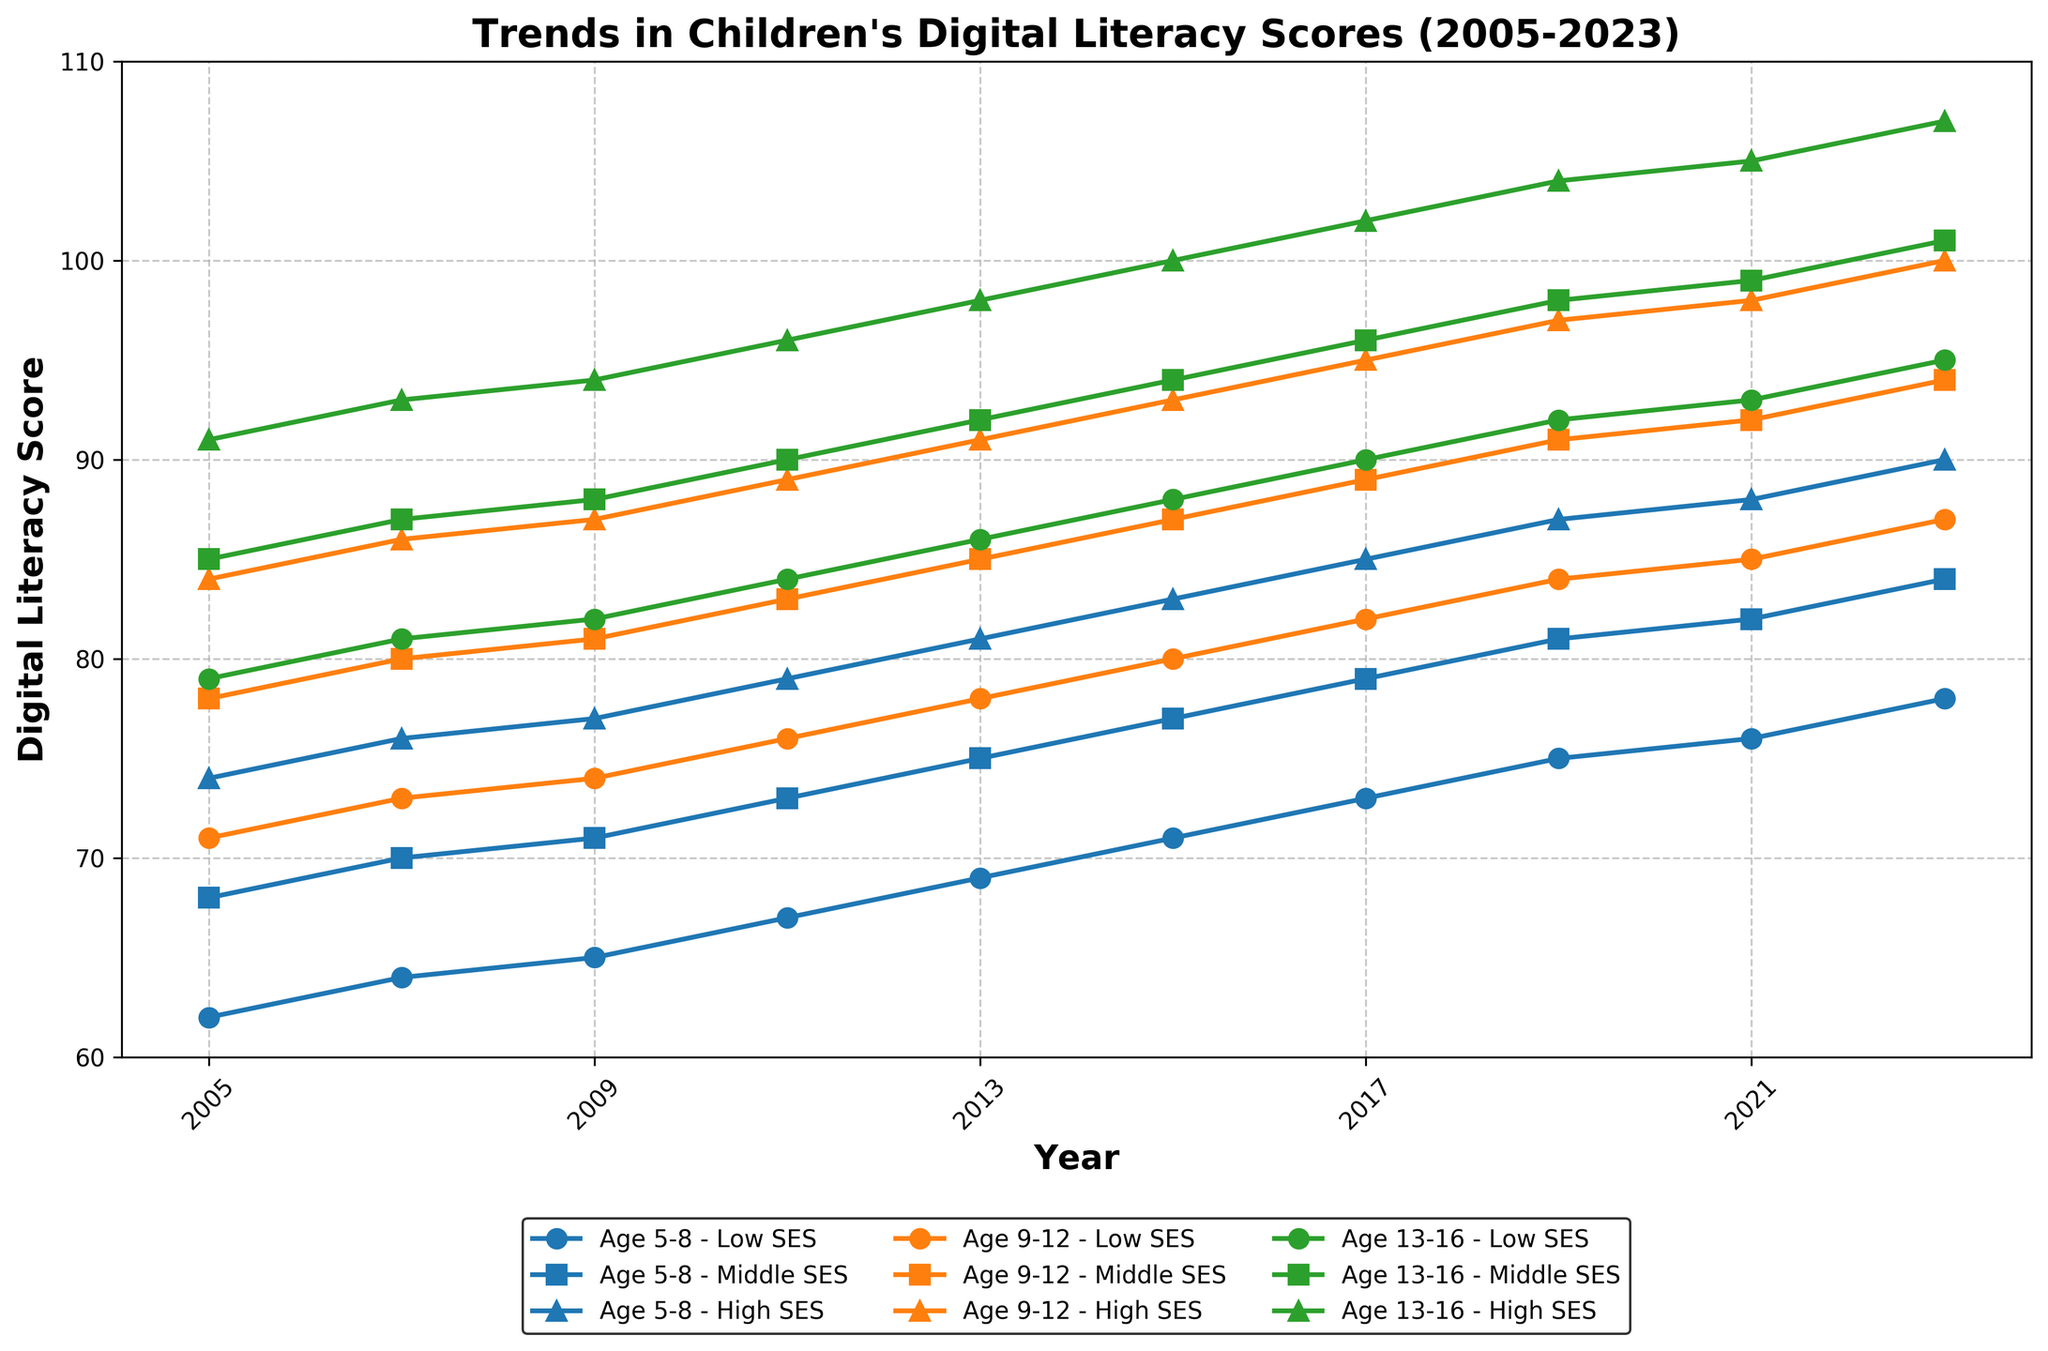What age group showed the highest improvement in digital literacy scores from 2005 to 2023? To find the age group with the highest improvement, we need to calculate the difference between the scores in 2023 and 2005 for each age group. For Age 5-8 (Average of SES levels): (78+84+90)/3 - (62+68+74)/3 = 84 - 68 = 16. For Age 9-12: (87+94+100)/3 - (71+78+84)/3 = 94 - 77.67 ≈ 16.33. For Age 13-16: (95+101+107)/3 - (79+85+91)/3 = 101 - 85 = 16. Age 9-12 has the highest improvement of 16.33 points.
Answer: Age 9-12 In 2015, which socioeconomic status had the lowest digital literacy score for children aged 9-12? To find the lowest score in 2015 for children aged 9-12, look at the three SES levels: Low SES (80), Middle SES (87), and High SES (93). The lowest score among these is 80.
Answer: Low SES Between 2009 and 2019, how did the digital literacy scores change for children aged 5-8 with High SES? To find the change, we subtract the 2009 score from the 2019 score for children aged 5-8 with High SES: 87 - 77 = 10. The score increased by 10 points.
Answer: Increased by 10 points Which socioeconomic group consistently had the highest digital literacy scores across all age groups and years? To determine this, we observe each line's position for the SES groups over the entire period. The High SES lines for each age group (green) are consistently at the top across all years.
Answer: High SES How does the digital literacy score for children aged 13-16 with Low SES in 2023 compare to children aged 5-8 with High SES in 2005? First, find the scores: Age 13-16 Low SES in 2023 is 95, and Age 5-8 High SES in 2005 is 74. Comparing these, 95 > 74. The 2023 score for children aged 13-16 with Low SES is higher by 21 points.
Answer: 95 is higher by 21 points What is the average digital literacy score for children aged 9-12 across all socioeconomic statuses in 2023? We calculate the average of the scores for Low, Middle, and High SES for children aged 9-12 in 2023: (87+94+100)/3 = 281/3 ≈ 93.67.
Answer: Approximately 93.67 In which year did the digital literacy scores for children aged 5-8 with Low SES first reach 70? We look for the year when the score for children aged 5-8 with Low SES first equals or exceeds 70. The score reaches 70 in 2007.
Answer: 2007 Compare the digital literacy improvement from 2005 to 2023 for children aged 5-8 Low SES and 13-16 High SES. Which group had a greater increase? Calculate each group's improvement: Age 5-8 Low SES: 78 - 62 = 16. Age 13-16 High SES: 107 - 91 = 16. The improvements are equal, both increasing by 16 points.
Answer: Both are equal with an increase of 16 points 